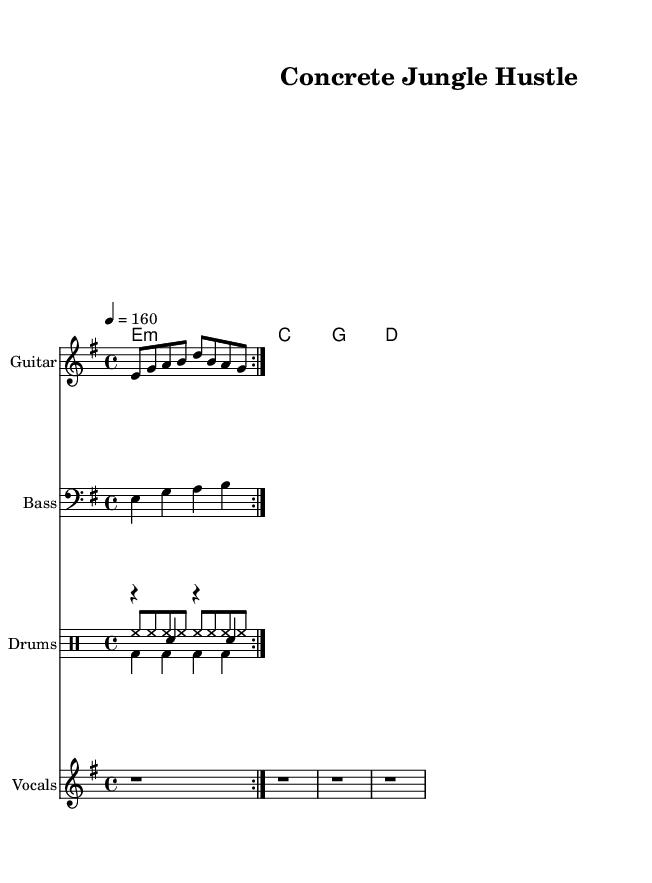What is the key signature of this music? The key signature is E minor, which has one sharp (F#).
Answer: E minor What is the time signature of this piece? The time signature is indicated by the numeral "4/4" at the beginning of the score, which signifies four beats per measure.
Answer: 4/4 What is the tempo marking of the music? The tempo marking is "4 = 160," signifying a speed of 160 beats per minute, or quarter notes played at that speed.
Answer: 160 How many measures are intended for the guitar riff section? The guitar riff section is repeated for a total of two measures as indicated by the "repeat volta" notation, showing that the riff is played twice.
Answer: 2 What is the overall theme expressed in the lyrics? The lyrics reflect the struggles of hustlers in an urban setting, particularly in dodging landlords and making ends meet, resonating with the punk themes of rebellion and survival.
Answer: Urban struggles Which instruments are featured in this piece? The piece features guitar, bass, and drums, each represented by their respective staves in the score.
Answer: Guitar, Bass, Drums What type of rhythm is primarily used in the bass line? The bass line uses quarter notes, as indicated by the "4" in the time signature, suggesting the foundational rhythmic feel typical in punk rock music.
Answer: Quarter notes 